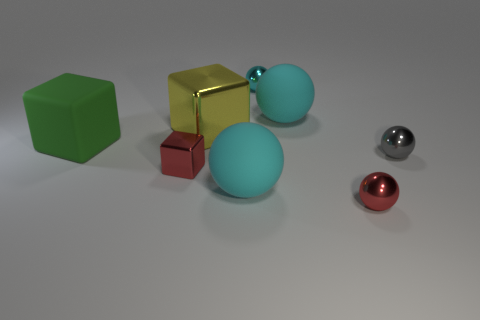Is there anything else that has the same size as the matte cube?
Give a very brief answer. Yes. Is the color of the big matte sphere that is behind the big yellow object the same as the large ball in front of the large yellow metal thing?
Provide a succinct answer. Yes. What is the cube that is on the right side of the large green object and behind the gray shiny ball made of?
Make the answer very short. Metal. Are there fewer green rubber blocks that are on the right side of the big green thing than small things that are in front of the tiny cyan metal thing?
Your answer should be very brief. Yes. How many other things are the same size as the gray metal object?
Your answer should be compact. 3. What shape is the large matte thing that is on the left side of the cyan sphere that is in front of the tiny shiny ball on the right side of the red sphere?
Provide a short and direct response. Cube. How many brown objects are either tiny shiny balls or large balls?
Your answer should be compact. 0. There is a matte sphere in front of the large metallic object; what number of red blocks are right of it?
Your response must be concise. 0. Is there any other thing of the same color as the big metallic cube?
Your answer should be very brief. No. There is a large yellow thing that is the same material as the small gray thing; what shape is it?
Offer a very short reply. Cube. 